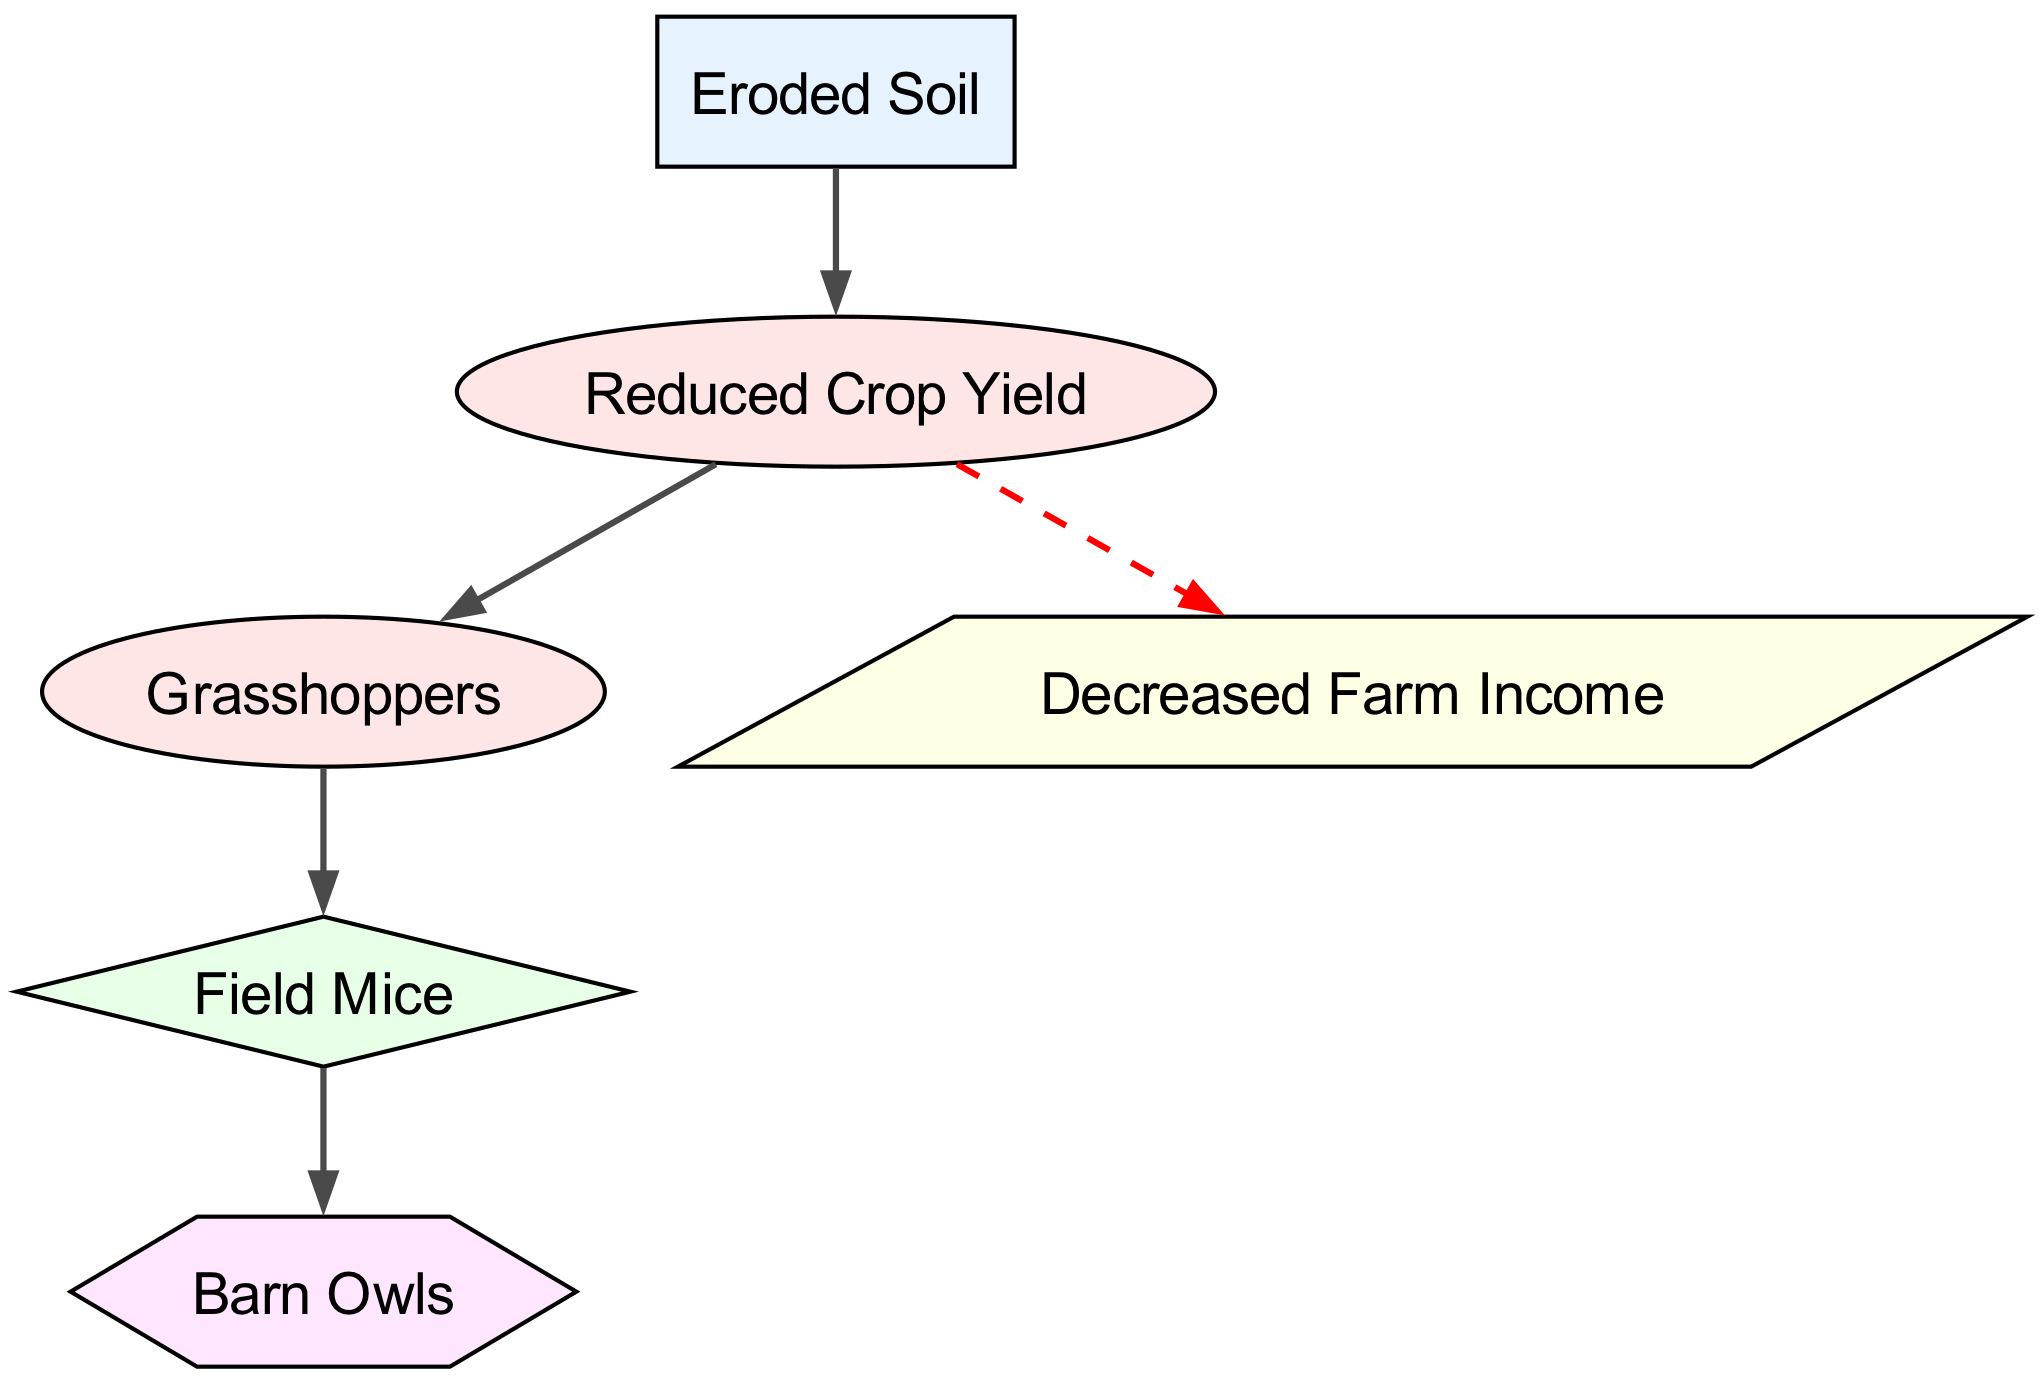What is the base element in the food chain? The base element is "Eroded Soil," which serves as the foundation for the food chain depicted in the diagram.
Answer: Eroded Soil How many primary consumers are identified in the diagram? There are two primary consumers: "Reduced Crop Yield" and "Grasshoppers." Counting these nodes gives us a total of two.
Answer: 2 What element directly consumes "Reduced Crop Yield"? "Grasshoppers" directly consumes "Reduced Crop Yield," as there is an arrow showing the flow from Reduced Crop Yield to Grasshoppers in the diagram.
Answer: Grasshoppers Which consumer is impacted by "Reduced Crop Yield"? "Decreased Farm Income" is the element impacted by "Reduced Crop Yield," indicated by a dashed arrow pointing from Reduced Crop Yield to Decreased Farm Income.
Answer: Decreased Farm Income What type of consumer is "Field Mice"? "Field Mice" is identified as a secondary consumer in the diagram, as it consumes "Grasshoppers," which places it in that category.
Answer: Secondary consumer Which element is the top-tier consumer in the food chain? "Barn Owls" is the top-tier consumer in this food chain as it consumes "Field Mice," representing the highest level in the hierarchy.
Answer: Barn Owls How does soil erosion affect agricultural ecosystems in this diagram? Soil erosion leads to "Eroded Soil," which reduces crop yield and creates a cascading effect resulting in decreased income for farmers as depicted in the relationships of the food chain.
Answer: Decreased Farm Income What is the effect on farm income linked to soil erosion? "Decreased Farm Income" is directly linked to "Reduced Crop Yield," showing that as soil erosion leads to reduced yield, it negatively impacts the income of farmers.
Answer: Decreased Farm Income 